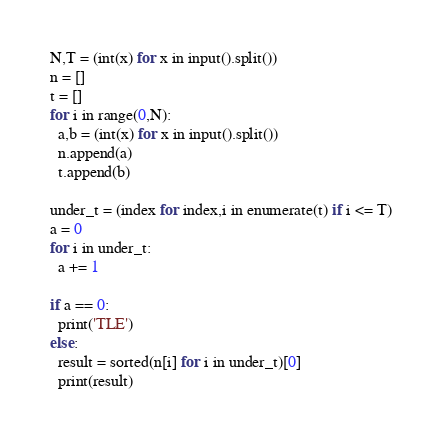Convert code to text. <code><loc_0><loc_0><loc_500><loc_500><_Python_>N,T = (int(x) for x in input().split())
n = []
t = []
for i in range(0,N):
  a,b = (int(x) for x in input().split())
  n.append(a)
  t.append(b)

under_t = (index for index,i in enumerate(t) if i <= T)
a = 0
for i in under_t:
  a += 1

if a == 0:
  print('TLE')
else:  
  result = sorted(n[i] for i in under_t)[0]
  print(result)</code> 